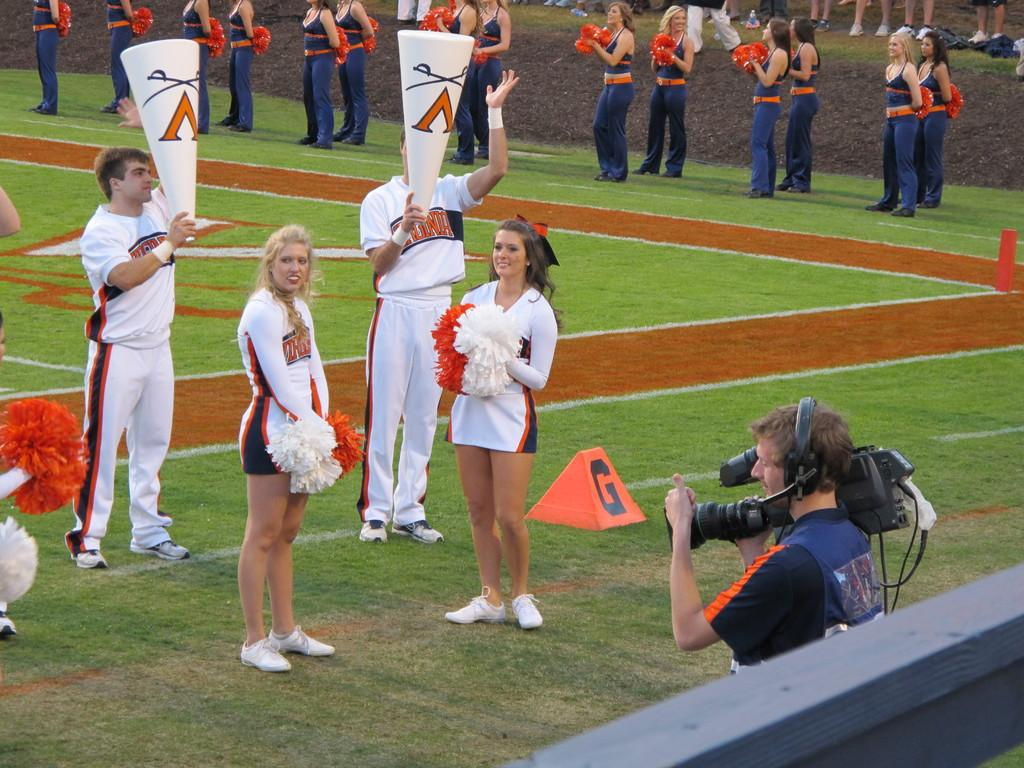<image>
Relay a brief, clear account of the picture shown. cheerleaders standing next to a G on a field 